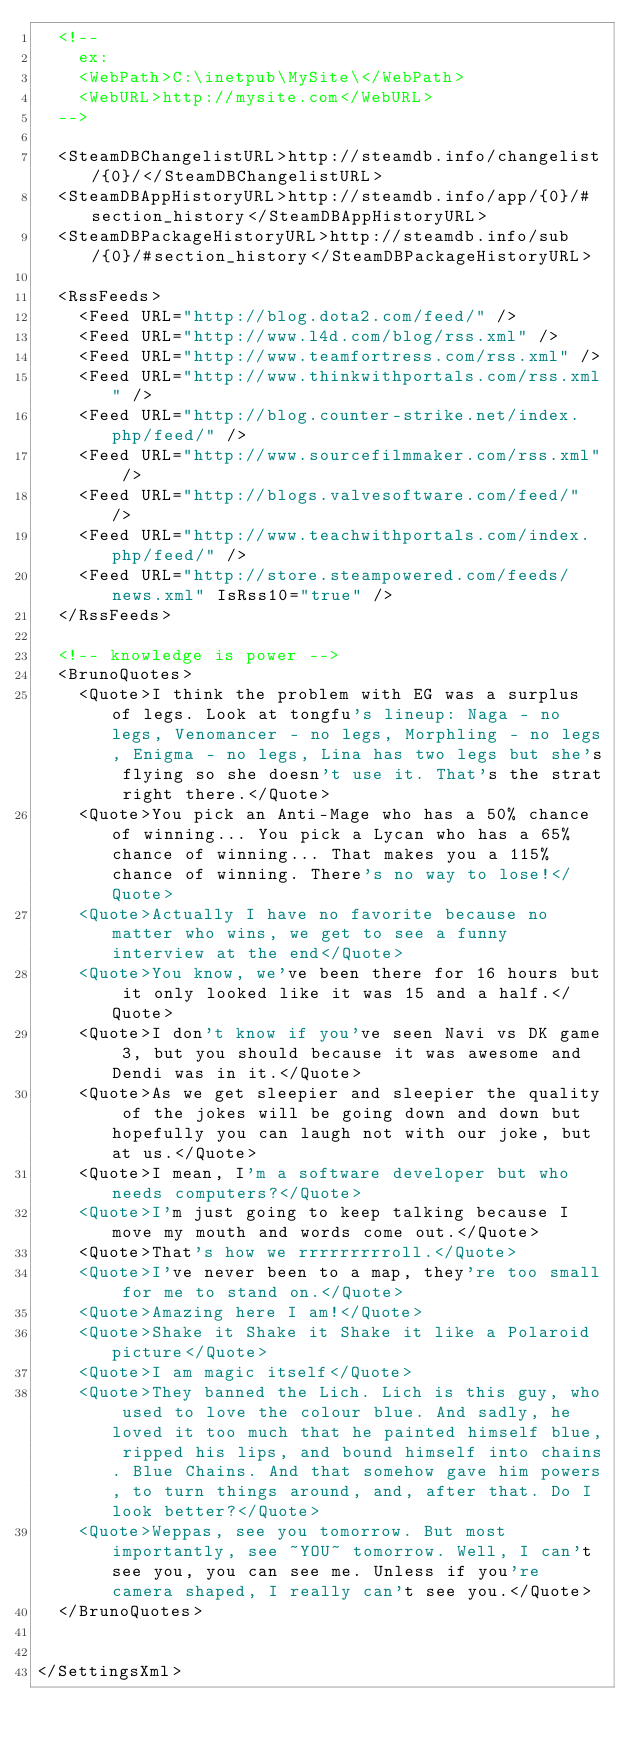<code> <loc_0><loc_0><loc_500><loc_500><_XML_>	<!--
		ex:
		<WebPath>C:\inetpub\MySite\</WebPath>
		<WebURL>http://mysite.com</WebURL>
	-->
  
	<SteamDBChangelistURL>http://steamdb.info/changelist/{0}/</SteamDBChangelistURL>
	<SteamDBAppHistoryURL>http://steamdb.info/app/{0}/#section_history</SteamDBAppHistoryURL>
	<SteamDBPackageHistoryURL>http://steamdb.info/sub/{0}/#section_history</SteamDBPackageHistoryURL>

	<RssFeeds>
		<Feed URL="http://blog.dota2.com/feed/" />
		<Feed URL="http://www.l4d.com/blog/rss.xml" />
		<Feed URL="http://www.teamfortress.com/rss.xml" />
		<Feed URL="http://www.thinkwithportals.com/rss.xml" />
		<Feed URL="http://blog.counter-strike.net/index.php/feed/" />
		<Feed URL="http://www.sourcefilmmaker.com/rss.xml" />
		<Feed URL="http://blogs.valvesoftware.com/feed/" />
		<Feed URL="http://www.teachwithportals.com/index.php/feed/" />
		<Feed URL="http://store.steampowered.com/feeds/news.xml" IsRss10="true" />
	</RssFeeds>

	<!-- knowledge is power -->
	<BrunoQuotes>
		<Quote>I think the problem with EG was a surplus of legs. Look at tongfu's lineup: Naga - no legs, Venomancer - no legs, Morphling - no legs, Enigma - no legs, Lina has two legs but she's flying so she doesn't use it. That's the strat right there.</Quote>
		<Quote>You pick an Anti-Mage who has a 50% chance of winning... You pick a Lycan who has a 65% chance of winning... That makes you a 115% chance of winning. There's no way to lose!</Quote>
		<Quote>Actually I have no favorite because no matter who wins, we get to see a funny interview at the end</Quote>
		<Quote>You know, we've been there for 16 hours but it only looked like it was 15 and a half.</Quote>
		<Quote>I don't know if you've seen Navi vs DK game 3, but you should because it was awesome and Dendi was in it.</Quote>
		<Quote>As we get sleepier and sleepier the quality of the jokes will be going down and down but hopefully you can laugh not with our joke, but at us.</Quote>
		<Quote>I mean, I'm a software developer but who needs computers?</Quote>
		<Quote>I'm just going to keep talking because I move my mouth and words come out.</Quote>
		<Quote>That's how we rrrrrrrrroll.</Quote>
		<Quote>I've never been to a map, they're too small for me to stand on.</Quote>
		<Quote>Amazing here I am!</Quote>
		<Quote>Shake it Shake it Shake it like a Polaroid picture</Quote>
		<Quote>I am magic itself</Quote>
		<Quote>They banned the Lich. Lich is this guy, who used to love the colour blue. And sadly, he loved it too much that he painted himself blue, ripped his lips, and bound himself into chains. Blue Chains. And that somehow gave him powers, to turn things around, and, after that. Do I look better?</Quote>
		<Quote>Weppas, see you tomorrow. But most importantly, see ~YOU~ tomorrow. Well, I can't see you, you can see me. Unless if you're camera shaped, I really can't see you.</Quote>
	</BrunoQuotes>

	
</SettingsXml>
</code> 